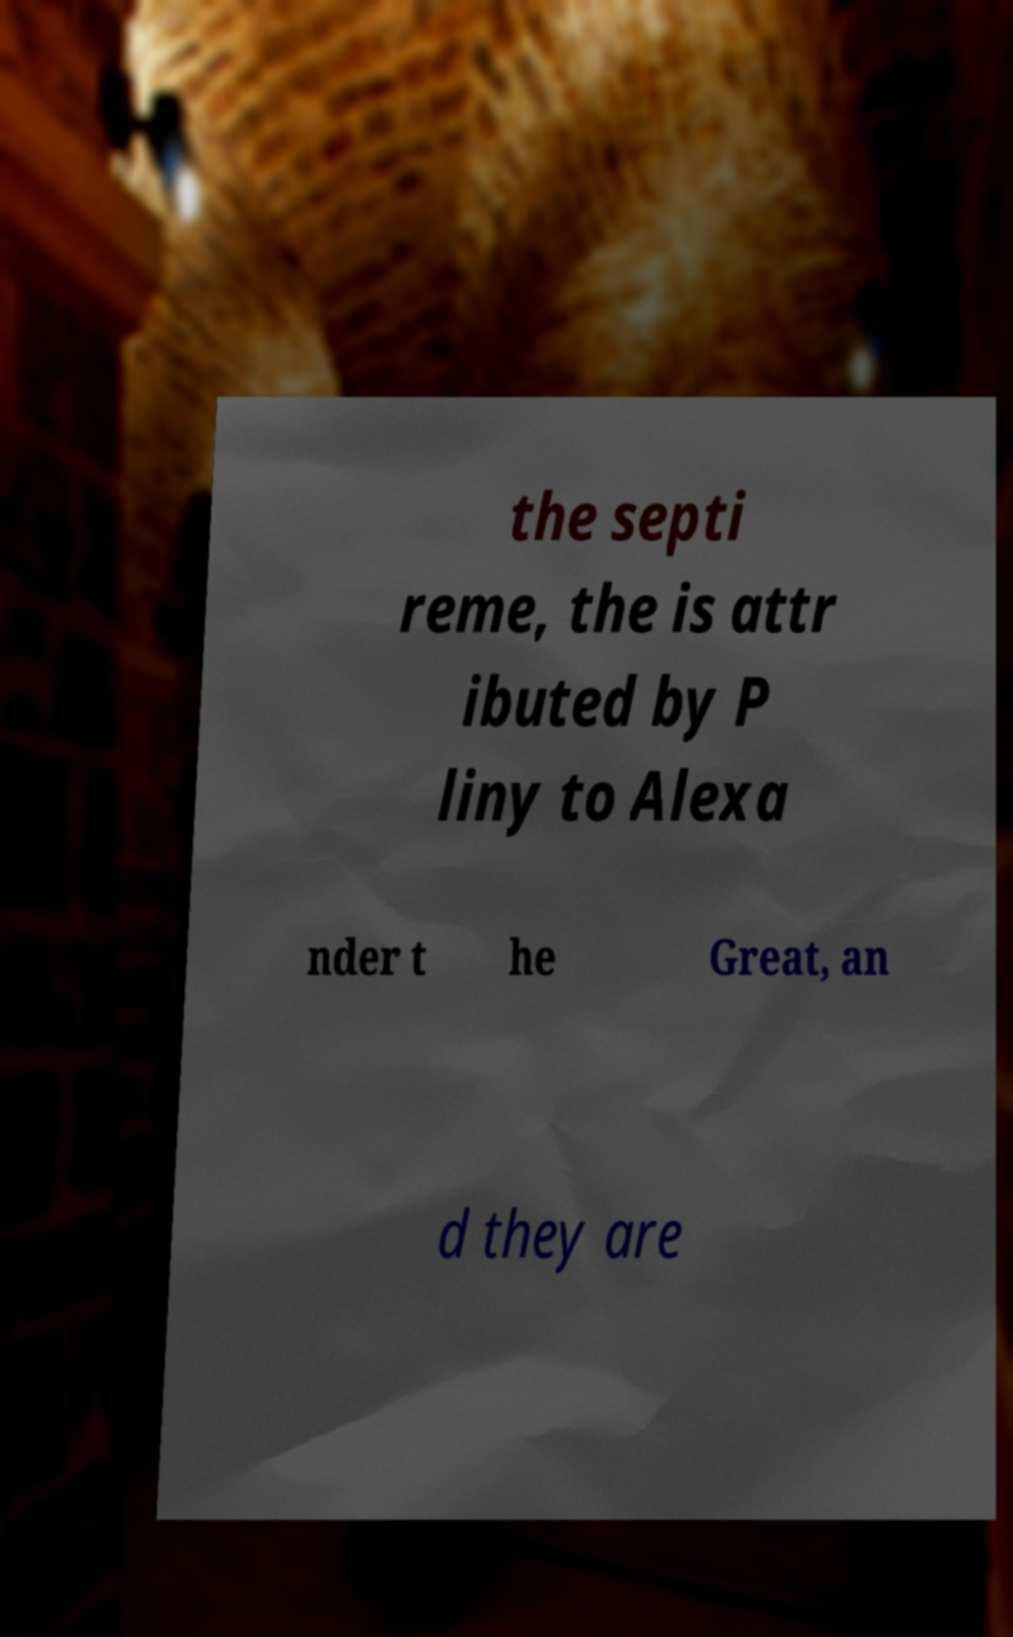For documentation purposes, I need the text within this image transcribed. Could you provide that? the septi reme, the is attr ibuted by P liny to Alexa nder t he Great, an d they are 